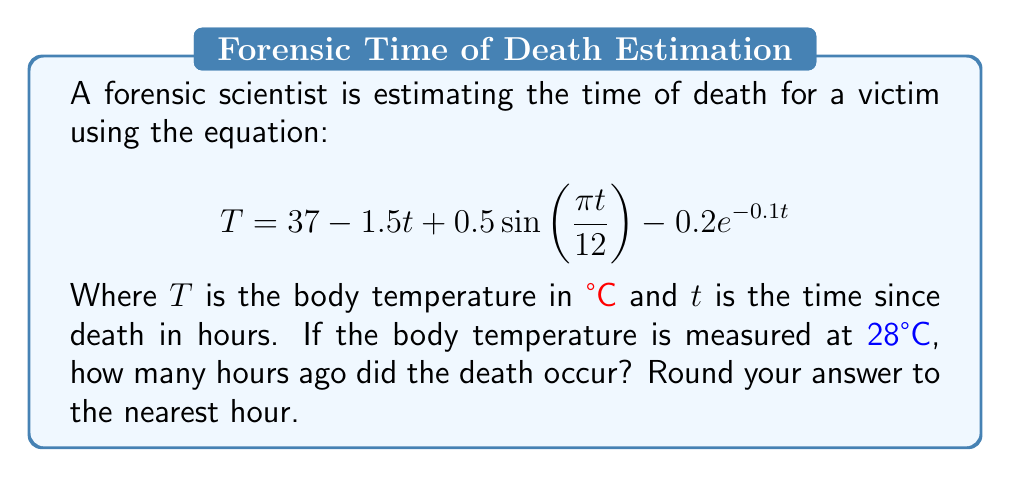Provide a solution to this math problem. To solve this problem, we need to find the value of $t$ when $T = 28$. This involves solving the equation:

$$28 = 37 - 1.5t + 0.5\sin(\frac{\pi t}{12}) - 0.2e^{-0.1t}$$

This equation is complex and cannot be solved algebraically. We need to use a numerical method, such as the Newton-Raphson method or a graphing calculator.

However, we can make an initial estimate:

1) Ignore the sine and exponential terms as they are relatively small:
   $$28 \approx 37 - 1.5t$$

2) Solve for $t$:
   $$-9 \approx -1.5t$$
   $$t \approx 6$$

3) This gives us a starting point of around 6 hours.

4) Using a graphing calculator or computer software, we can refine this estimate by plotting the function:

   $$f(t) = 37 - 1.5t + 0.5\sin(\frac{\pi t}{12}) - 0.2e^{-0.1t} - 28$$

5) Finding the root of this function (where it crosses the x-axis) gives us the solution.

6) The solution is approximately 6.2 hours.

7) Rounding to the nearest hour gives us 6 hours.

This method allows for a quick estimation that can be crucial in time-sensitive forensic investigations.
Answer: 6 hours 